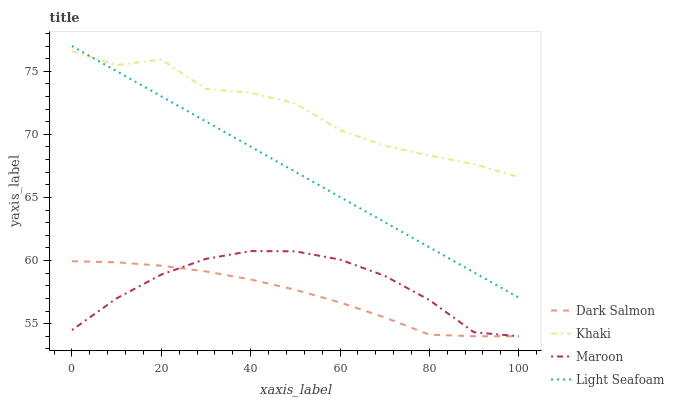Does Dark Salmon have the minimum area under the curve?
Answer yes or no. Yes. Does Khaki have the maximum area under the curve?
Answer yes or no. Yes. Does Khaki have the minimum area under the curve?
Answer yes or no. No. Does Dark Salmon have the maximum area under the curve?
Answer yes or no. No. Is Light Seafoam the smoothest?
Answer yes or no. Yes. Is Khaki the roughest?
Answer yes or no. Yes. Is Dark Salmon the smoothest?
Answer yes or no. No. Is Dark Salmon the roughest?
Answer yes or no. No. Does Khaki have the lowest value?
Answer yes or no. No. Does Light Seafoam have the highest value?
Answer yes or no. Yes. Does Khaki have the highest value?
Answer yes or no. No. Is Dark Salmon less than Light Seafoam?
Answer yes or no. Yes. Is Khaki greater than Dark Salmon?
Answer yes or no. Yes. Does Khaki intersect Light Seafoam?
Answer yes or no. Yes. Is Khaki less than Light Seafoam?
Answer yes or no. No. Is Khaki greater than Light Seafoam?
Answer yes or no. No. Does Dark Salmon intersect Light Seafoam?
Answer yes or no. No. 